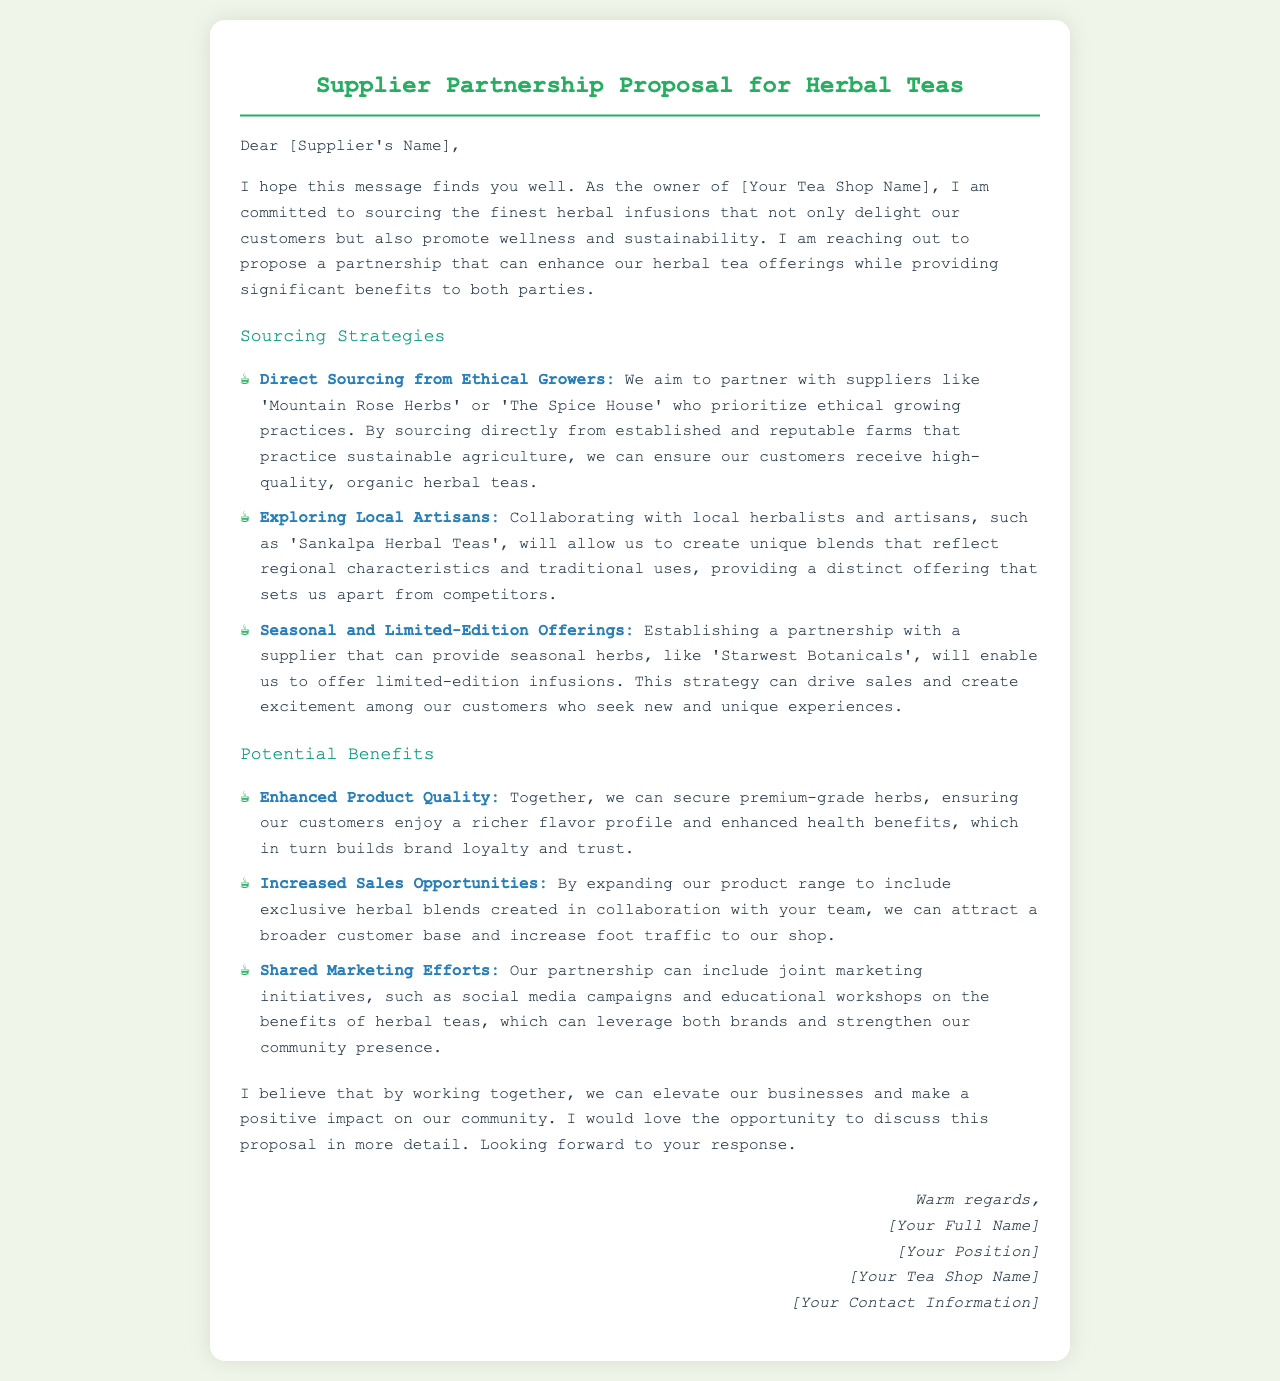What is the title of the document? The title of the document is indicated at the top of the letter.
Answer: Supplier Partnership Proposal for Herbal Teas Who is the owner of the tea shop? The name of the tea shop owner is mentioned in the closing of the letter.
Answer: [Your Full Name] What is one sourcing strategy mentioned in the document? The document lists several strategies for sourcing herbal teas.
Answer: Direct Sourcing from Ethical Growers What benefit is highlighted in the section on potential benefits? The document outlines specific advantages for the partnership with suppliers.
Answer: Enhanced Product Quality Which supplier is associated with seasonal herbs? The proposal names a specific supplier for seasonal herbs in the sourcing strategies.
Answer: Starwest Botanicals What is the purpose of the letter? The main goal of the document is indicated in the introduction.
Answer: Propose a partnership What type of initiatives are suggested for shared marketing efforts? The document proposes specific activities related to marketing partnerships.
Answer: Joint marketing initiatives How does the owner wish to communicate further about the proposal? The letter expresses a desire for continued dialogue on the proposal.
Answer: Discuss this proposal in more detail Who is the targeted audience of this proposal? The greeting at the beginning of the letter indicates the intended audience.
Answer: Supplier's Name 